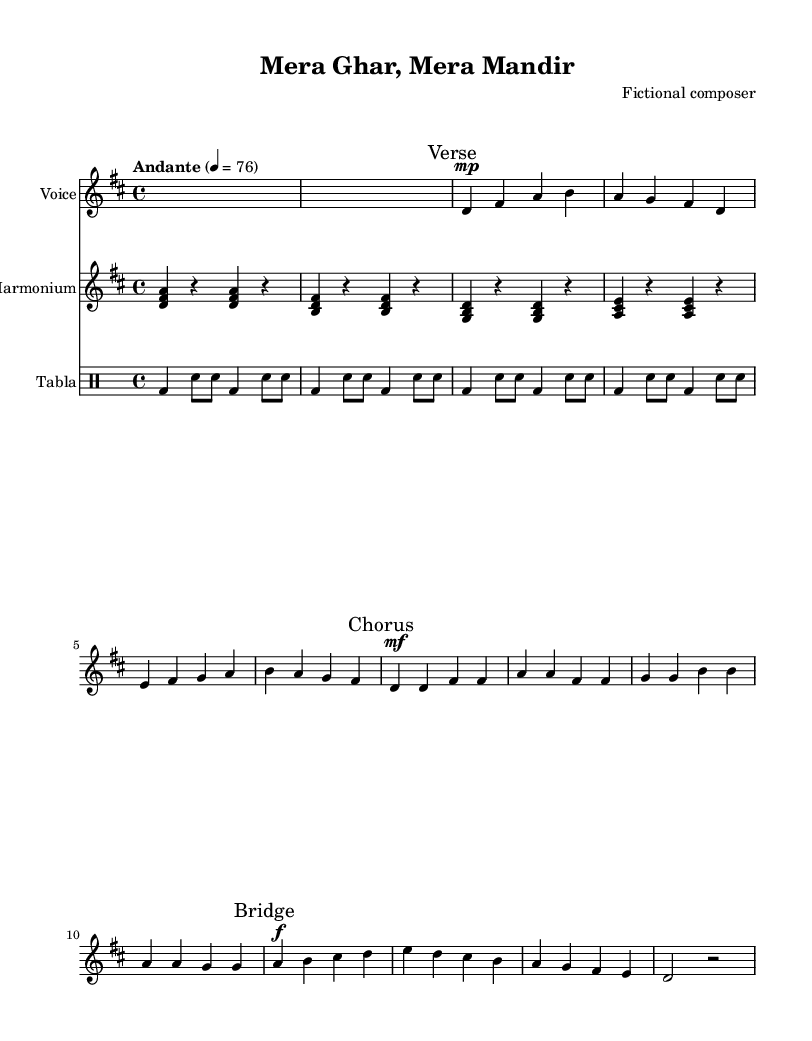What is the key signature of this music? The key signature indicated at the beginning of the score is D major, which contains two sharps (F# and C#).
Answer: D major What is the time signature of this piece? The time signature shown at the beginning is 4/4, which means there are four beats per measure.
Answer: 4/4 What is the tempo marking for this piece? The tempo marking indicates "Andante," which typically suggests a moderately slow pace.
Answer: Andante How many sections are there in this composition? The score is divided into three main sections: Verse, Chorus, and Bridge, as indicated by the marks throughout the music.
Answer: Three Which instrument is featured prominently in this score alongside voice? The harmonium is indicated as a primary instrument accompanying the vocal melody in the score.
Answer: Harmonium What dynamic marking is used at the beginning of the Chorus? The dynamic marking for the Chorus section is marked as "mf," which stands for mezzoforte, meaning moderately loud.
Answer: mf What notation indicates the end of a phrase in the melody? The end of a phrase in the melody is indicated by a double bar line, although it may not always be shown in simple melodic parts. For this example, the rests signify breaks in the melody instead.
Answer: Rests 